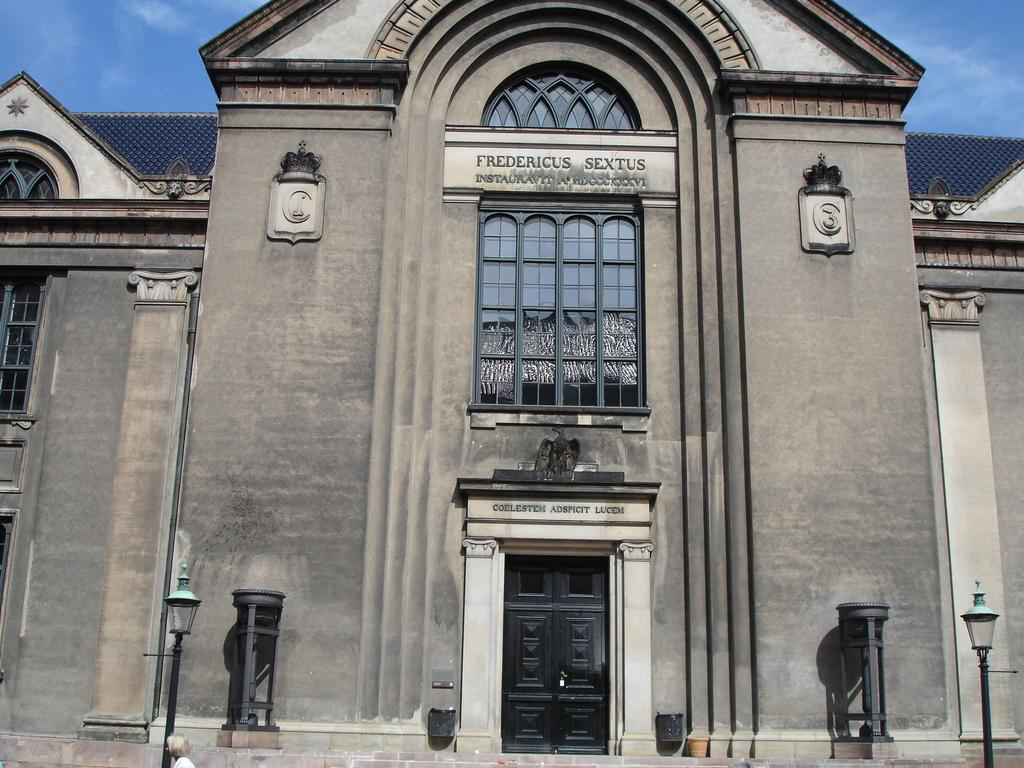What type of structure is present in the image? There is a building in the image. What type of lighting is present in the image? There are pole lights in the image. What is written or displayed on the building? There is text on the building. How would you describe the sky in the image? The sky is blue and cloudy. Is there any entrance visible in the image? Yes, there is a door visible in the image. What type of yarn is the doll holding during the meeting with the stranger? The image does not show the doll holding any yarn, nor is there a meeting with a stranger depicted. 